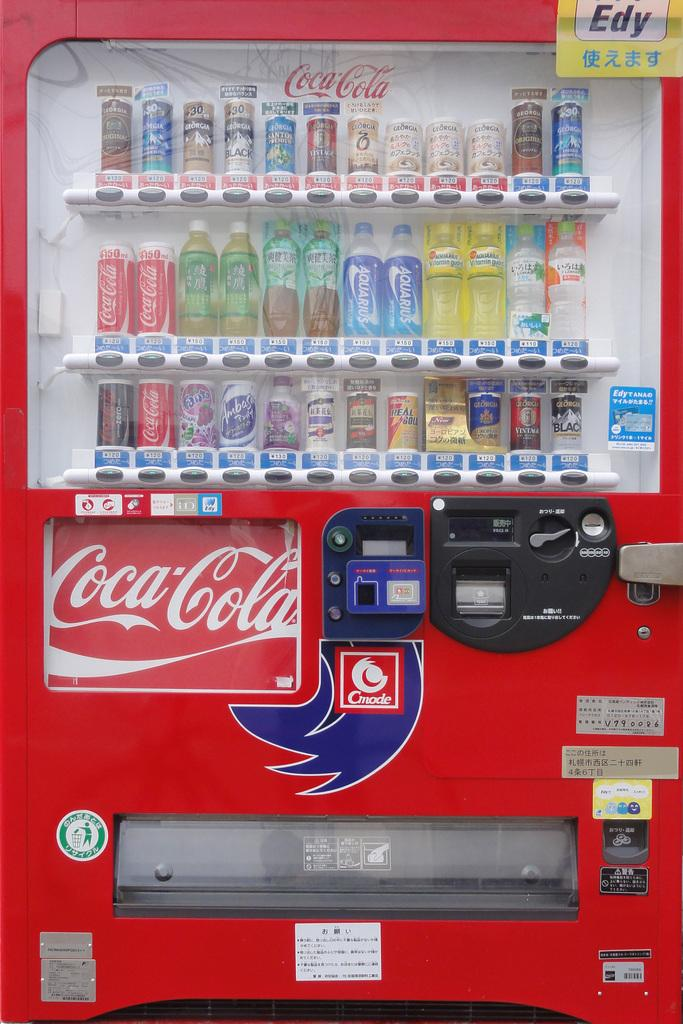<image>
Summarize the visual content of the image. The Coca Cola branded vending machine also has other drinks including Fanta Grape, Georgia Black, and Aquarius. 